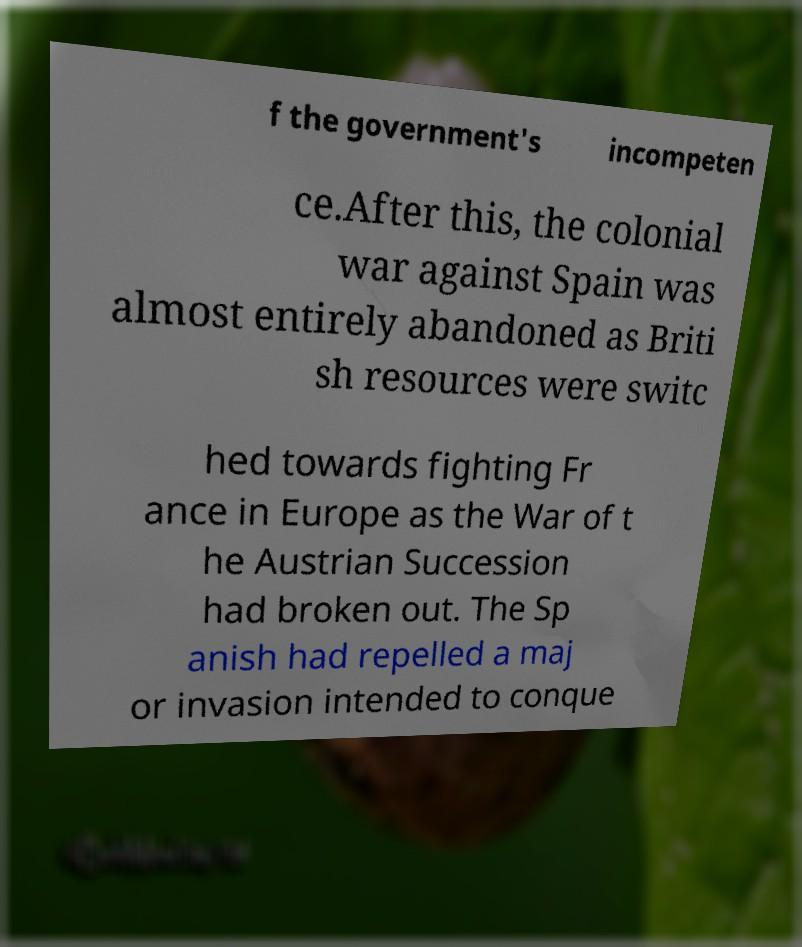What messages or text are displayed in this image? I need them in a readable, typed format. f the government's incompeten ce.After this, the colonial war against Spain was almost entirely abandoned as Briti sh resources were switc hed towards fighting Fr ance in Europe as the War of t he Austrian Succession had broken out. The Sp anish had repelled a maj or invasion intended to conque 